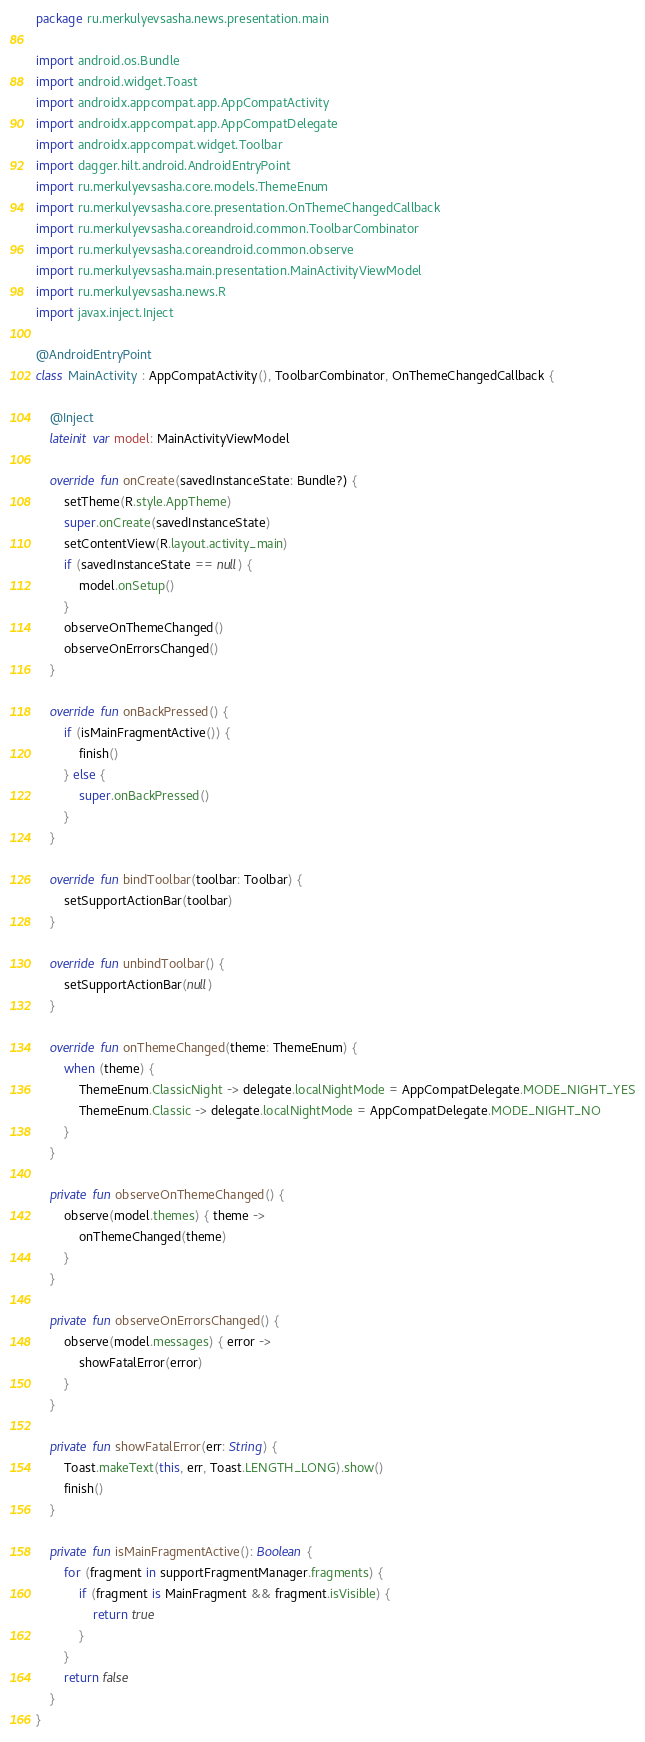<code> <loc_0><loc_0><loc_500><loc_500><_Kotlin_>package ru.merkulyevsasha.news.presentation.main

import android.os.Bundle
import android.widget.Toast
import androidx.appcompat.app.AppCompatActivity
import androidx.appcompat.app.AppCompatDelegate
import androidx.appcompat.widget.Toolbar
import dagger.hilt.android.AndroidEntryPoint
import ru.merkulyevsasha.core.models.ThemeEnum
import ru.merkulyevsasha.core.presentation.OnThemeChangedCallback
import ru.merkulyevsasha.coreandroid.common.ToolbarCombinator
import ru.merkulyevsasha.coreandroid.common.observe
import ru.merkulyevsasha.main.presentation.MainActivityViewModel
import ru.merkulyevsasha.news.R
import javax.inject.Inject

@AndroidEntryPoint
class MainActivity : AppCompatActivity(), ToolbarCombinator, OnThemeChangedCallback {

    @Inject
    lateinit var model: MainActivityViewModel

    override fun onCreate(savedInstanceState: Bundle?) {
        setTheme(R.style.AppTheme)
        super.onCreate(savedInstanceState)
        setContentView(R.layout.activity_main)
        if (savedInstanceState == null) {
            model.onSetup()
        }
        observeOnThemeChanged()
        observeOnErrorsChanged()
    }

    override fun onBackPressed() {
        if (isMainFragmentActive()) {
            finish()
        } else {
            super.onBackPressed()
        }
    }

    override fun bindToolbar(toolbar: Toolbar) {
        setSupportActionBar(toolbar)
    }

    override fun unbindToolbar() {
        setSupportActionBar(null)
    }

    override fun onThemeChanged(theme: ThemeEnum) {
        when (theme) {
            ThemeEnum.ClassicNight -> delegate.localNightMode = AppCompatDelegate.MODE_NIGHT_YES
            ThemeEnum.Classic -> delegate.localNightMode = AppCompatDelegate.MODE_NIGHT_NO
        }
    }

    private fun observeOnThemeChanged() {
        observe(model.themes) { theme ->
            onThemeChanged(theme)
        }
    }

    private fun observeOnErrorsChanged() {
        observe(model.messages) { error ->
            showFatalError(error)
        }
    }

    private fun showFatalError(err: String) {
        Toast.makeText(this, err, Toast.LENGTH_LONG).show()
        finish()
    }

    private fun isMainFragmentActive(): Boolean {
        for (fragment in supportFragmentManager.fragments) {
            if (fragment is MainFragment && fragment.isVisible) {
                return true
            }
        }
        return false
    }
}
</code> 